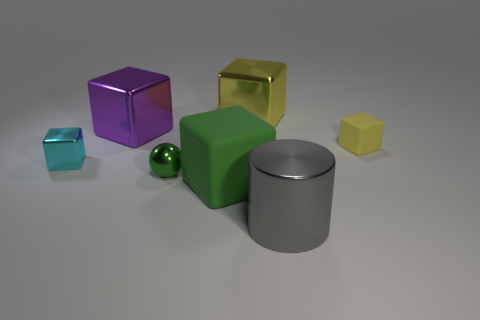Subtract all brown cubes. Subtract all brown spheres. How many cubes are left? 5 Add 2 big metal cylinders. How many objects exist? 9 Subtract all blocks. How many objects are left? 2 Add 6 tiny yellow blocks. How many tiny yellow blocks exist? 7 Subtract 0 red cylinders. How many objects are left? 7 Subtract all cyan blocks. Subtract all small green spheres. How many objects are left? 5 Add 6 big metal objects. How many big metal objects are left? 9 